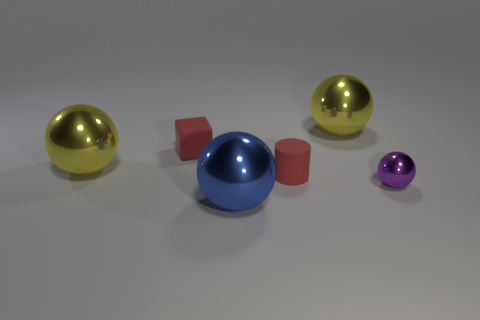Subtract all blue shiny balls. How many balls are left? 3 Subtract all yellow balls. How many balls are left? 2 Add 1 blue things. How many objects exist? 7 Subtract 3 spheres. How many spheres are left? 1 Subtract all spheres. How many objects are left? 2 Add 3 metal spheres. How many metal spheres are left? 7 Add 4 large shiny objects. How many large shiny objects exist? 7 Subtract 0 yellow cylinders. How many objects are left? 6 Subtract all purple blocks. Subtract all blue spheres. How many blocks are left? 1 Subtract all blue balls. How many green cylinders are left? 0 